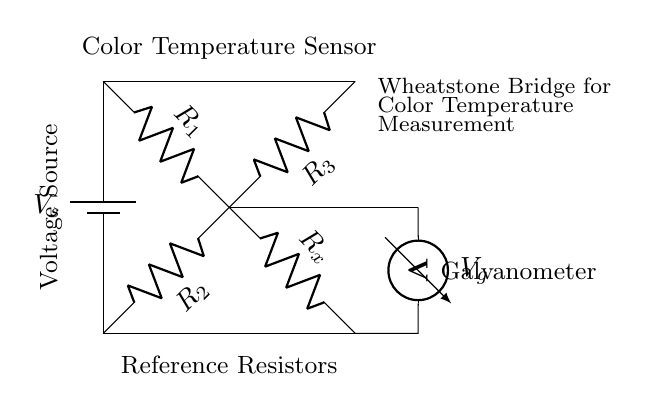What type of circuit is this? This circuit is a Wheatstone bridge, characterized by its four resistors configured in a diamond shape, used for precise measurement techniques.
Answer: Wheatstone bridge What component measures voltage in this circuit? The voltmeter, indicated in the circuit as measuring the potential difference across a particular section of the bridge, is the component that measures voltage.
Answer: Voltmeter How many resistors are in this circuit? There are four resistors present in the Wheatstone bridge circuit as depicted in the diagram, including one variable resistor.
Answer: Four What does the galvanometer indicate? The galvanometer indicates the current flowing through it, which reflects the balance point of the Wheatstone bridge based on resistor values.
Answer: Current Which resistor is variable in this circuit? The resistor labeled as R_x is variable, allowing for adjustments to balance the bridge and measure the unknown resistance accurately.
Answer: R_x What is the purpose of using a Wheatstone bridge in this setting? The Wheatstone bridge is utilized for precise color temperature measurements in photography lighting, allowing for accurate adjustments and balances in lighting conditions.
Answer: Color temperature measurement 